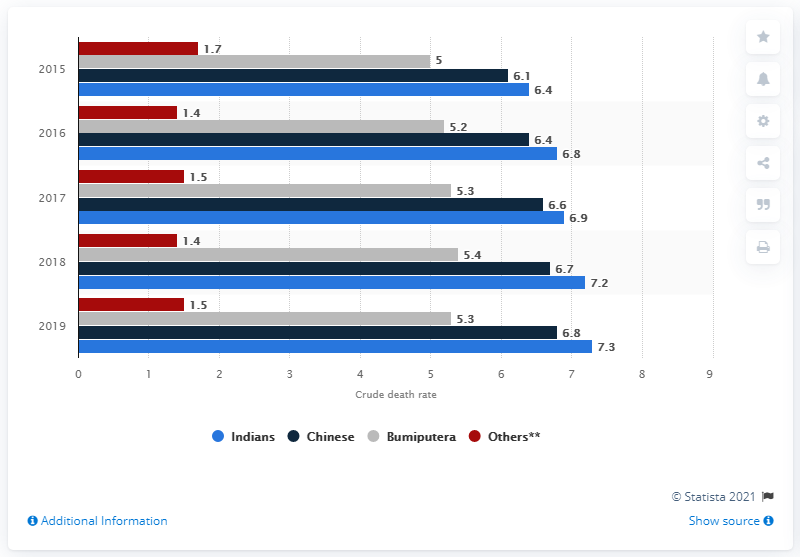Highlight a few significant elements in this photo. In 2019, the crude death rate for the ethnic Indian population in Malaysia was 7.3 per 1,000 people. 